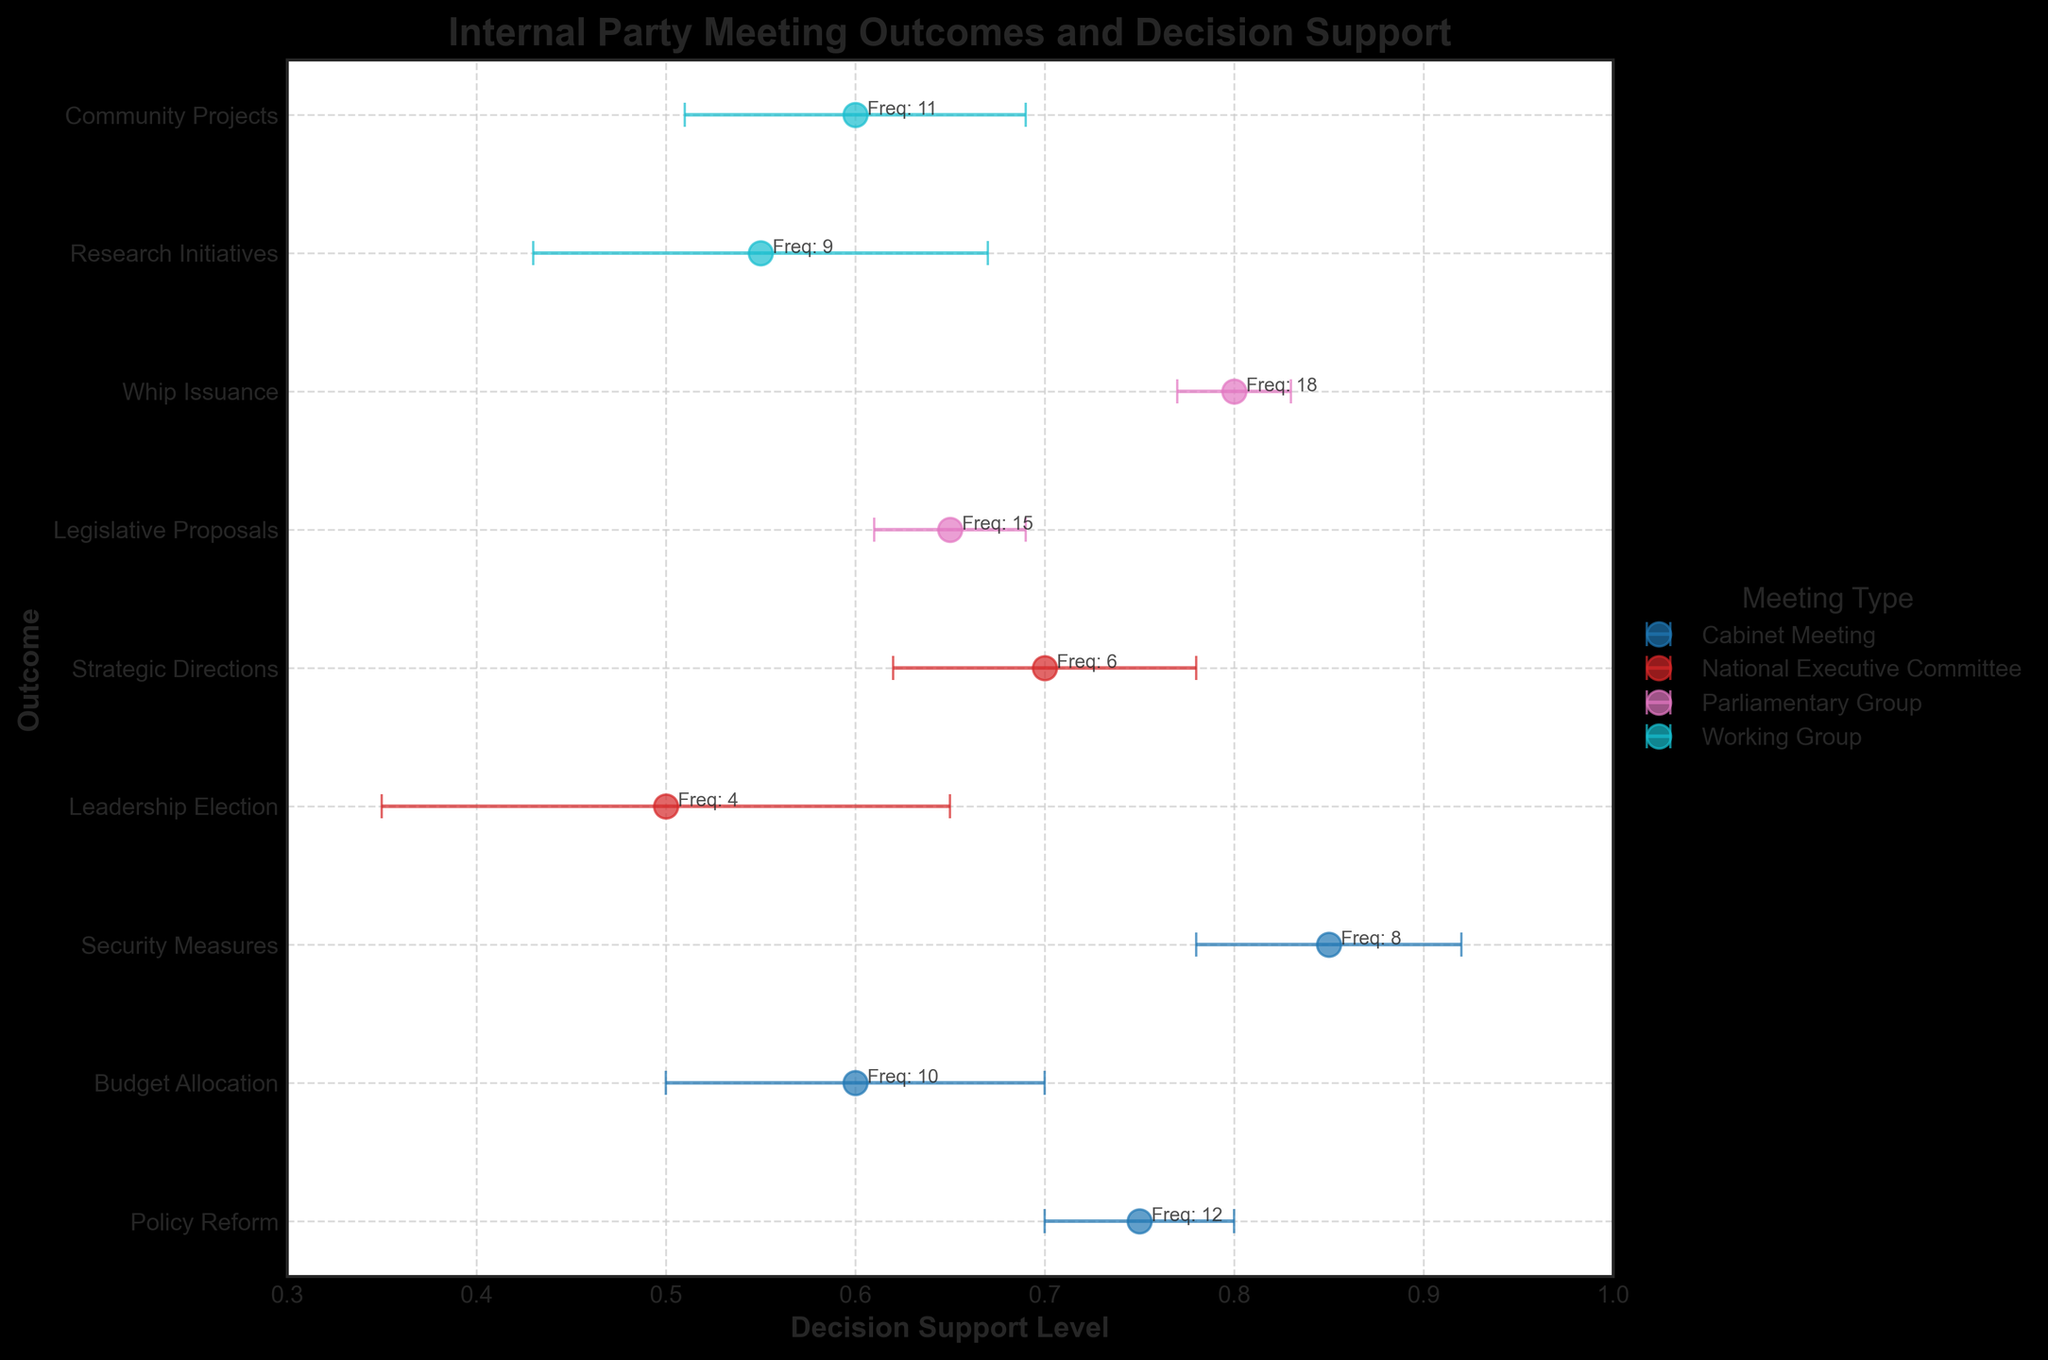Which meeting type has the highest decision support for any outcome? By looking at the x-axis which denotes the level of decision support, identify the dot positioned furthest to the right. This point, representing the "Whip Issuance" decision outcome by the "Parliamentary Group" with a decision support of 0.80 and an error margin of 0.03, is the highest.
Answer: Parliamentary Group (Whip Issuance) What is the outcome with the lowest decision support level, and which meeting does it belong to? Examine the x-axis for the lowest decision support value, identifying it as 0.50, which corresponds to the "Leadership Election" outcome in a "National Executive Committee" meeting.
Answer: Leadership Election (National Executive Committee) Which outcome has the largest error margin in decision support? Observe the horizontal error bars to see which one spans the widest on the x-axis. This is the "Leadership Election" outcome from the "National Executive Committee" meeting with an error margin of 0.15.
Answer: Leadership Election (National Executive Committee) Among the Cabinet Meetings, what is the average decision support level? Identify the decision support values for "Policy Reform," "Budget Allocation," and "Security Measures" outcomes in Cabinet Meetings: 0.75, 0.60, and 0.85 respectively. Calculate the average: (0.75 + 0.60 + 0.85) / 3 = 2.20 / 3 = 0.7333.
Answer: 0.7333 Which meeting type has the most consistent decision support levels (smallest error margins) across all its outcomes? Compare the error margins of outcomes within each meeting type: Cabinet Meeting (0.05, 0.10, 0.07), National Executive Committee (0.15, 0.08), Parliamentary Group (0.04, 0.03), and Working Group (0.12, 0.09). The Parliamentary Group has the smallest error margins.
Answer: Parliamentary Group Which meeting type has the highest frequency of meetings for a single outcome? Identify the "Frequency" annotations next to each dot and find the highest value. The "Parliamentary Group" with "Whip Issuance" has a frequency of 18, which is the highest.
Answer: Parliamentary Group (Whip Issuance) Which outcome from the Cabinet Meetings has the lowest decision support level, and what is its frequency? Within Cabinet Meetings, identify the "Budget Allocation" which has the lowest decision support level of 0.60, and its frequency is 10.
Answer: Budget Allocation, Frequency: 10 How many meeting types are presented in the figure, and what are they? Look at the legend of the figure to see which meeting types are represented. The four meeting types are: "Cabinet Meeting," "National Executive Committee," "Parliamentary Group," and "Working Group."
Answer: Four: Cabinet Meeting, National Executive Committee, Parliamentary Group, and Working Group By how much does the decision support level differ between "Legislative Proposals" and "Budget Allocation"? Determine the decision support levels for "Legislative Proposals" (0.65) and "Budget Allocation" (0.60). Calculate the difference: 0.65 - 0.60 = 0.05.
Answer: 0.05 